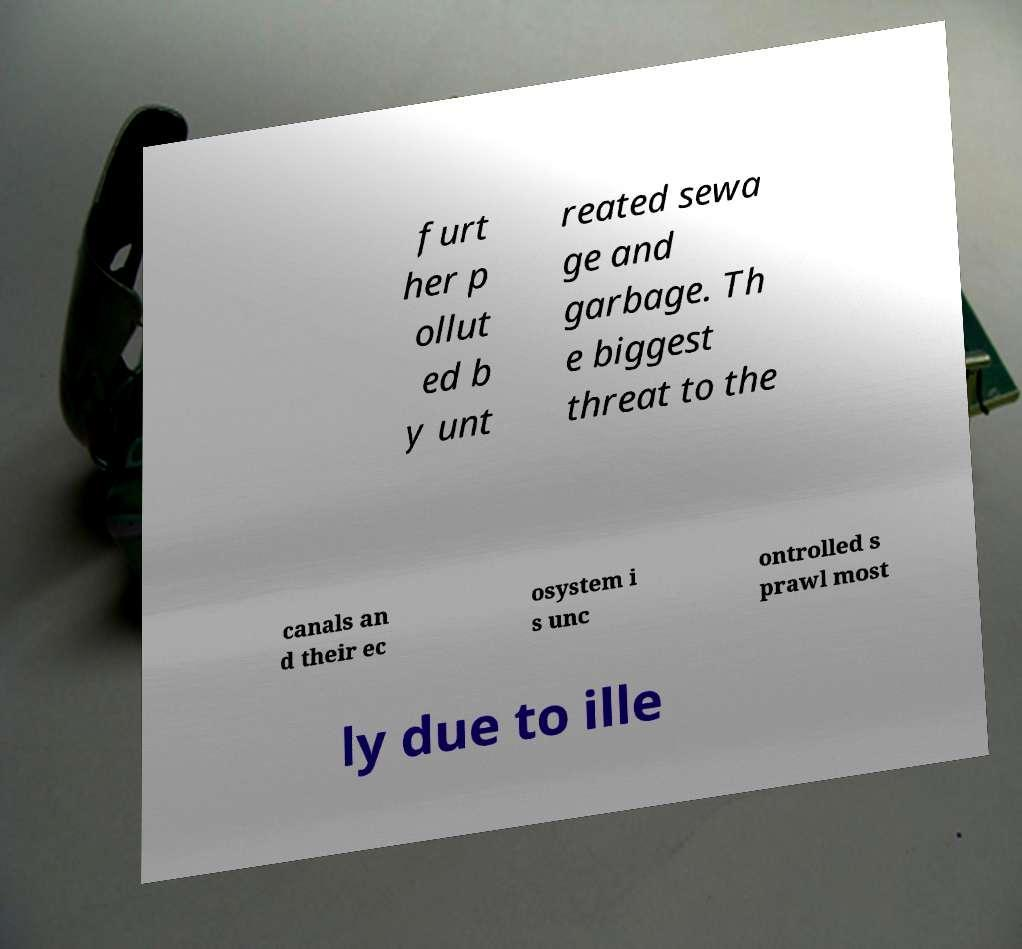Could you extract and type out the text from this image? furt her p ollut ed b y unt reated sewa ge and garbage. Th e biggest threat to the canals an d their ec osystem i s unc ontrolled s prawl most ly due to ille 